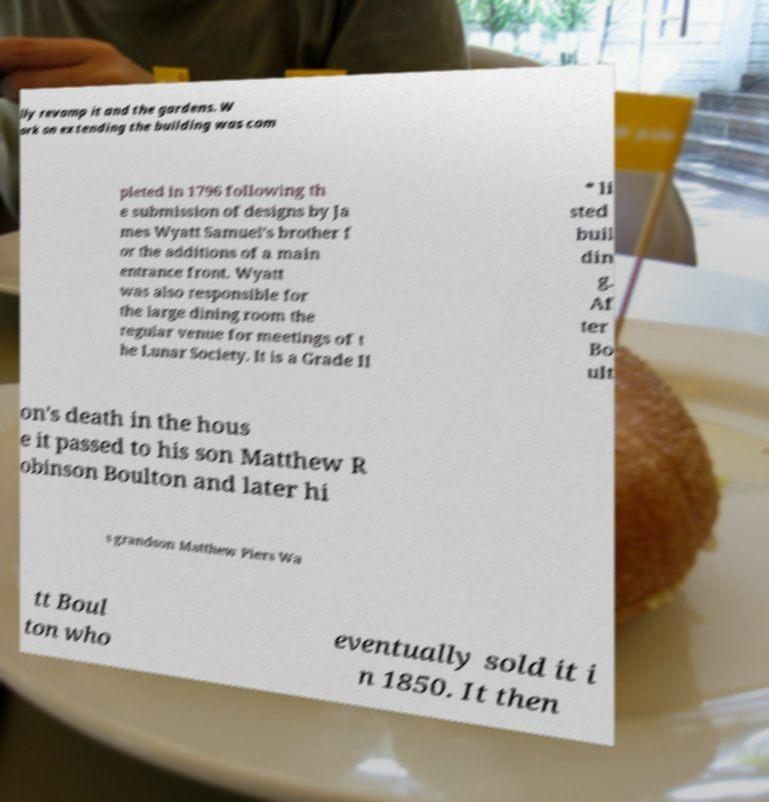There's text embedded in this image that I need extracted. Can you transcribe it verbatim? lly revamp it and the gardens. W ork on extending the building was com pleted in 1796 following th e submission of designs by Ja mes Wyatt Samuel's brother f or the additions of a main entrance front. Wyatt was also responsible for the large dining room the regular venue for meetings of t he Lunar Society. It is a Grade II * li sted buil din g. Af ter Bo ult on's death in the hous e it passed to his son Matthew R obinson Boulton and later hi s grandson Matthew Piers Wa tt Boul ton who eventually sold it i n 1850. It then 